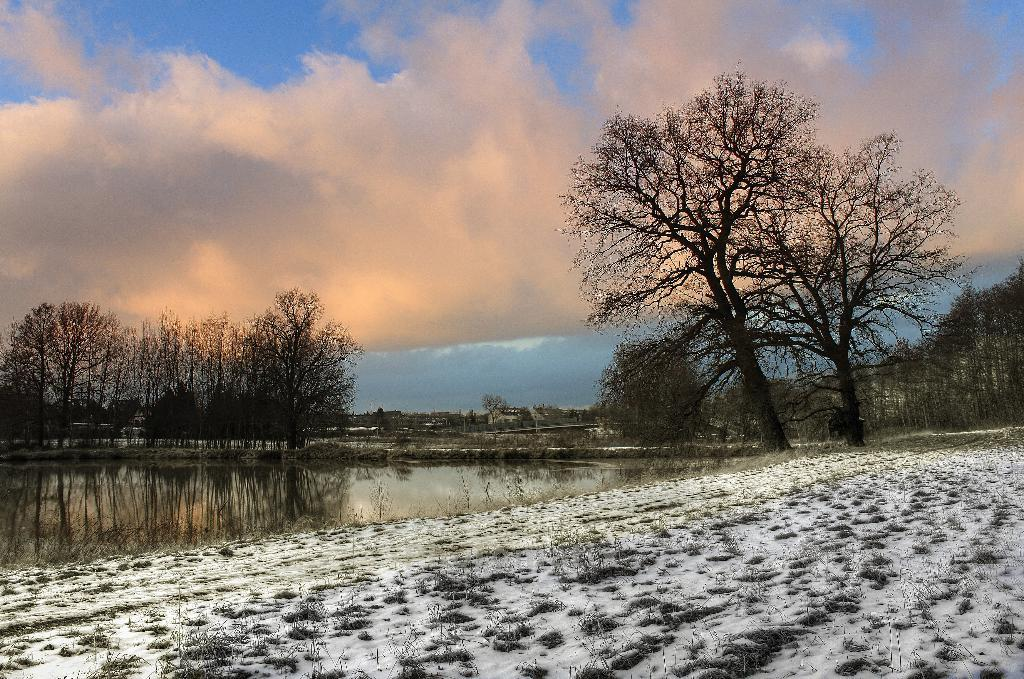What type of natural environment is depicted at the bottom of the image? There is snow at the bottom of the image. What can be seen on the left side of the image? There is water on the left side of the image. What type of vegetation is visible in the background of the image? There are trees in the background of the image. What is visible at the top of the image? The sky is visible at the top of the image. What type of baseball equipment can be seen in the image? There is no baseball equipment present in the image. What type of land is visible in the image? The image does not specifically depict land; it shows snow, water, trees, and sky. 